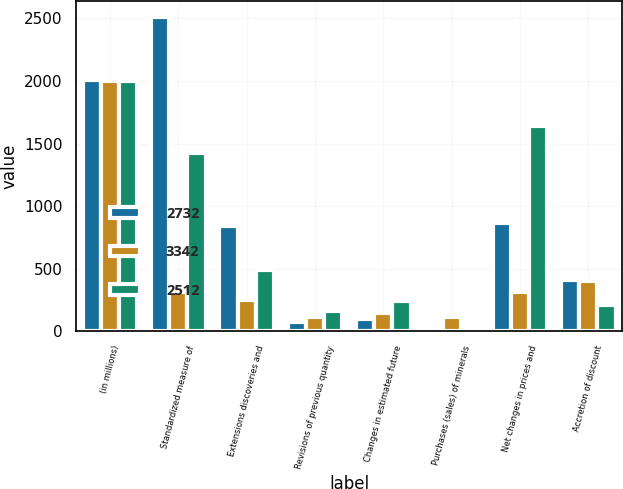Convert chart to OTSL. <chart><loc_0><loc_0><loc_500><loc_500><stacked_bar_chart><ecel><fcel>(in millions)<fcel>Standardized measure of<fcel>Extensions discoveries and<fcel>Revisions of previous quantity<fcel>Changes in estimated future<fcel>Purchases (sales) of minerals<fcel>Net changes in prices and<fcel>Accretion of discount<nl><fcel>2732<fcel>2004<fcel>2512<fcel>839<fcel>70<fcel>99<fcel>12<fcel>861<fcel>406<nl><fcel>3342<fcel>2003<fcel>312<fcel>247<fcel>115<fcel>148<fcel>115<fcel>312<fcel>405<nl><fcel>2512<fcel>2002<fcel>1428<fcel>486<fcel>158<fcel>243<fcel>13<fcel>1636<fcel>208<nl></chart> 